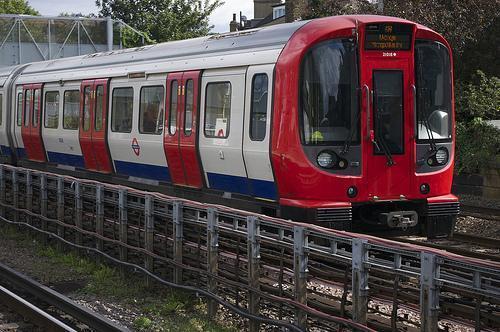How many trains are in this photo?
Give a very brief answer. 1. 